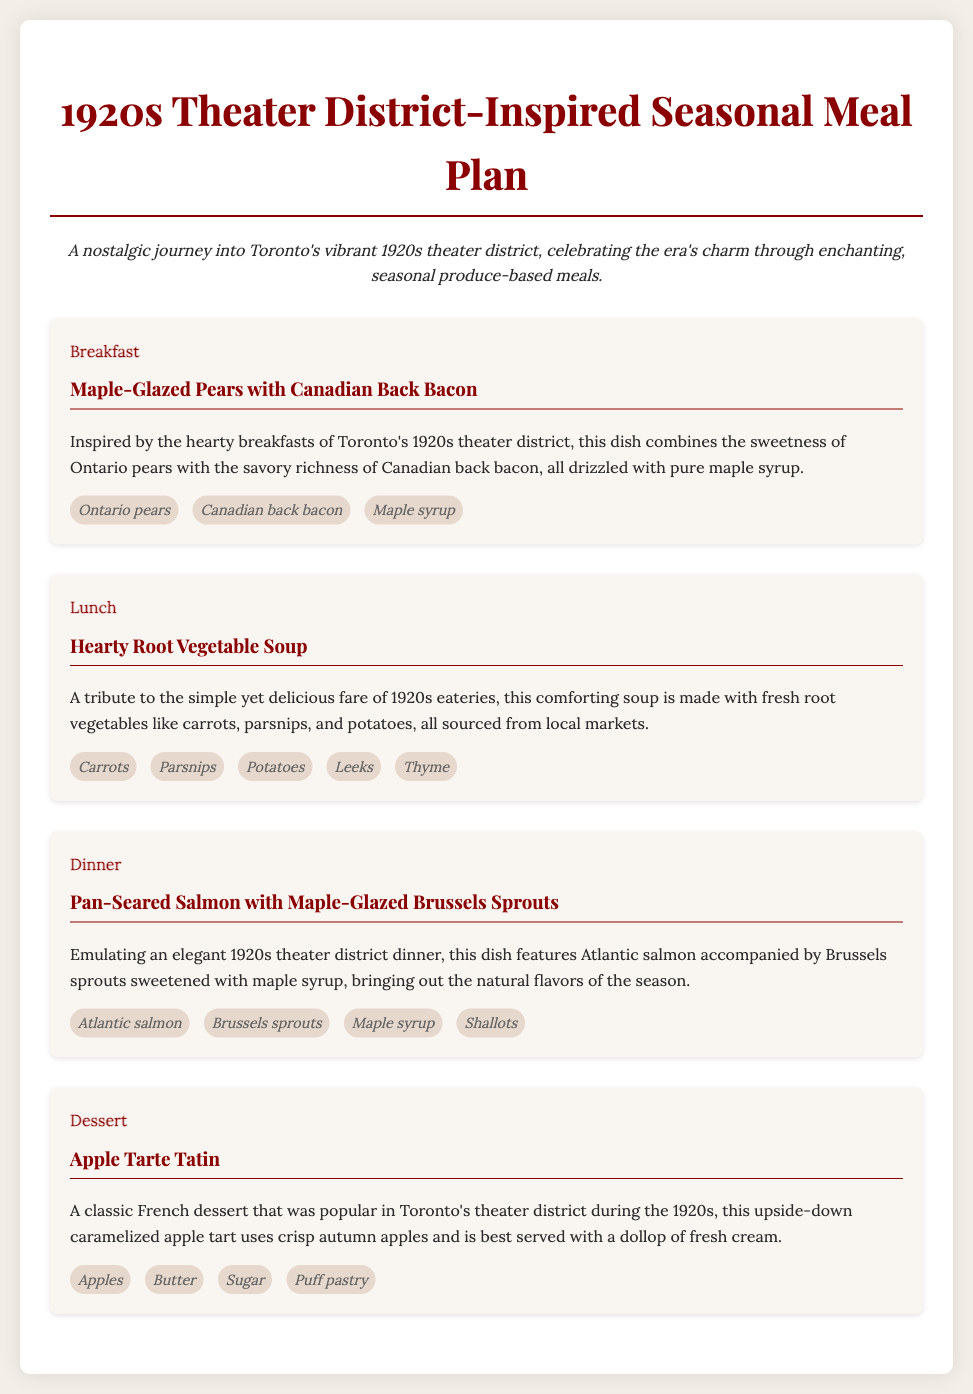What is the breakfast dish? The breakfast dish is mentioned in the meal section titled "Breakfast".
Answer: Maple-Glazed Pears with Canadian Back Bacon How many meals are listed in the plan? The document lists a total of four meals: breakfast, lunch, dinner, and dessert.
Answer: 4 What ingredient is used in all the meals? The ingredient used in the breakfast and dinner meals is mentioned in the descriptions of those meals.
Answer: Maple syrup What type of soup is featured for lunch? The lunch section describes the meal focusing on a specific type of soup.
Answer: Hearty Root Vegetable Soup Which fish is served for dinner? The dinner meal details a specific fish served as part of the main dish.
Answer: Atlantic salmon What type of dessert is included in the meal plan? The dessert meal section specifies the name of a classic French dessert.
Answer: Apple Tarte Tatin What vegetables are used in the lunch soup? The soup ingredients are listed in the meal section focused on lunch, mentioning several vegetables.
Answer: Carrots, Parsnips, Potatoes, Leeks, Thyme Which meal includes Canadian back bacon? The meal specifically describes the breakfast which mentions this ingredient.
Answer: Breakfast 